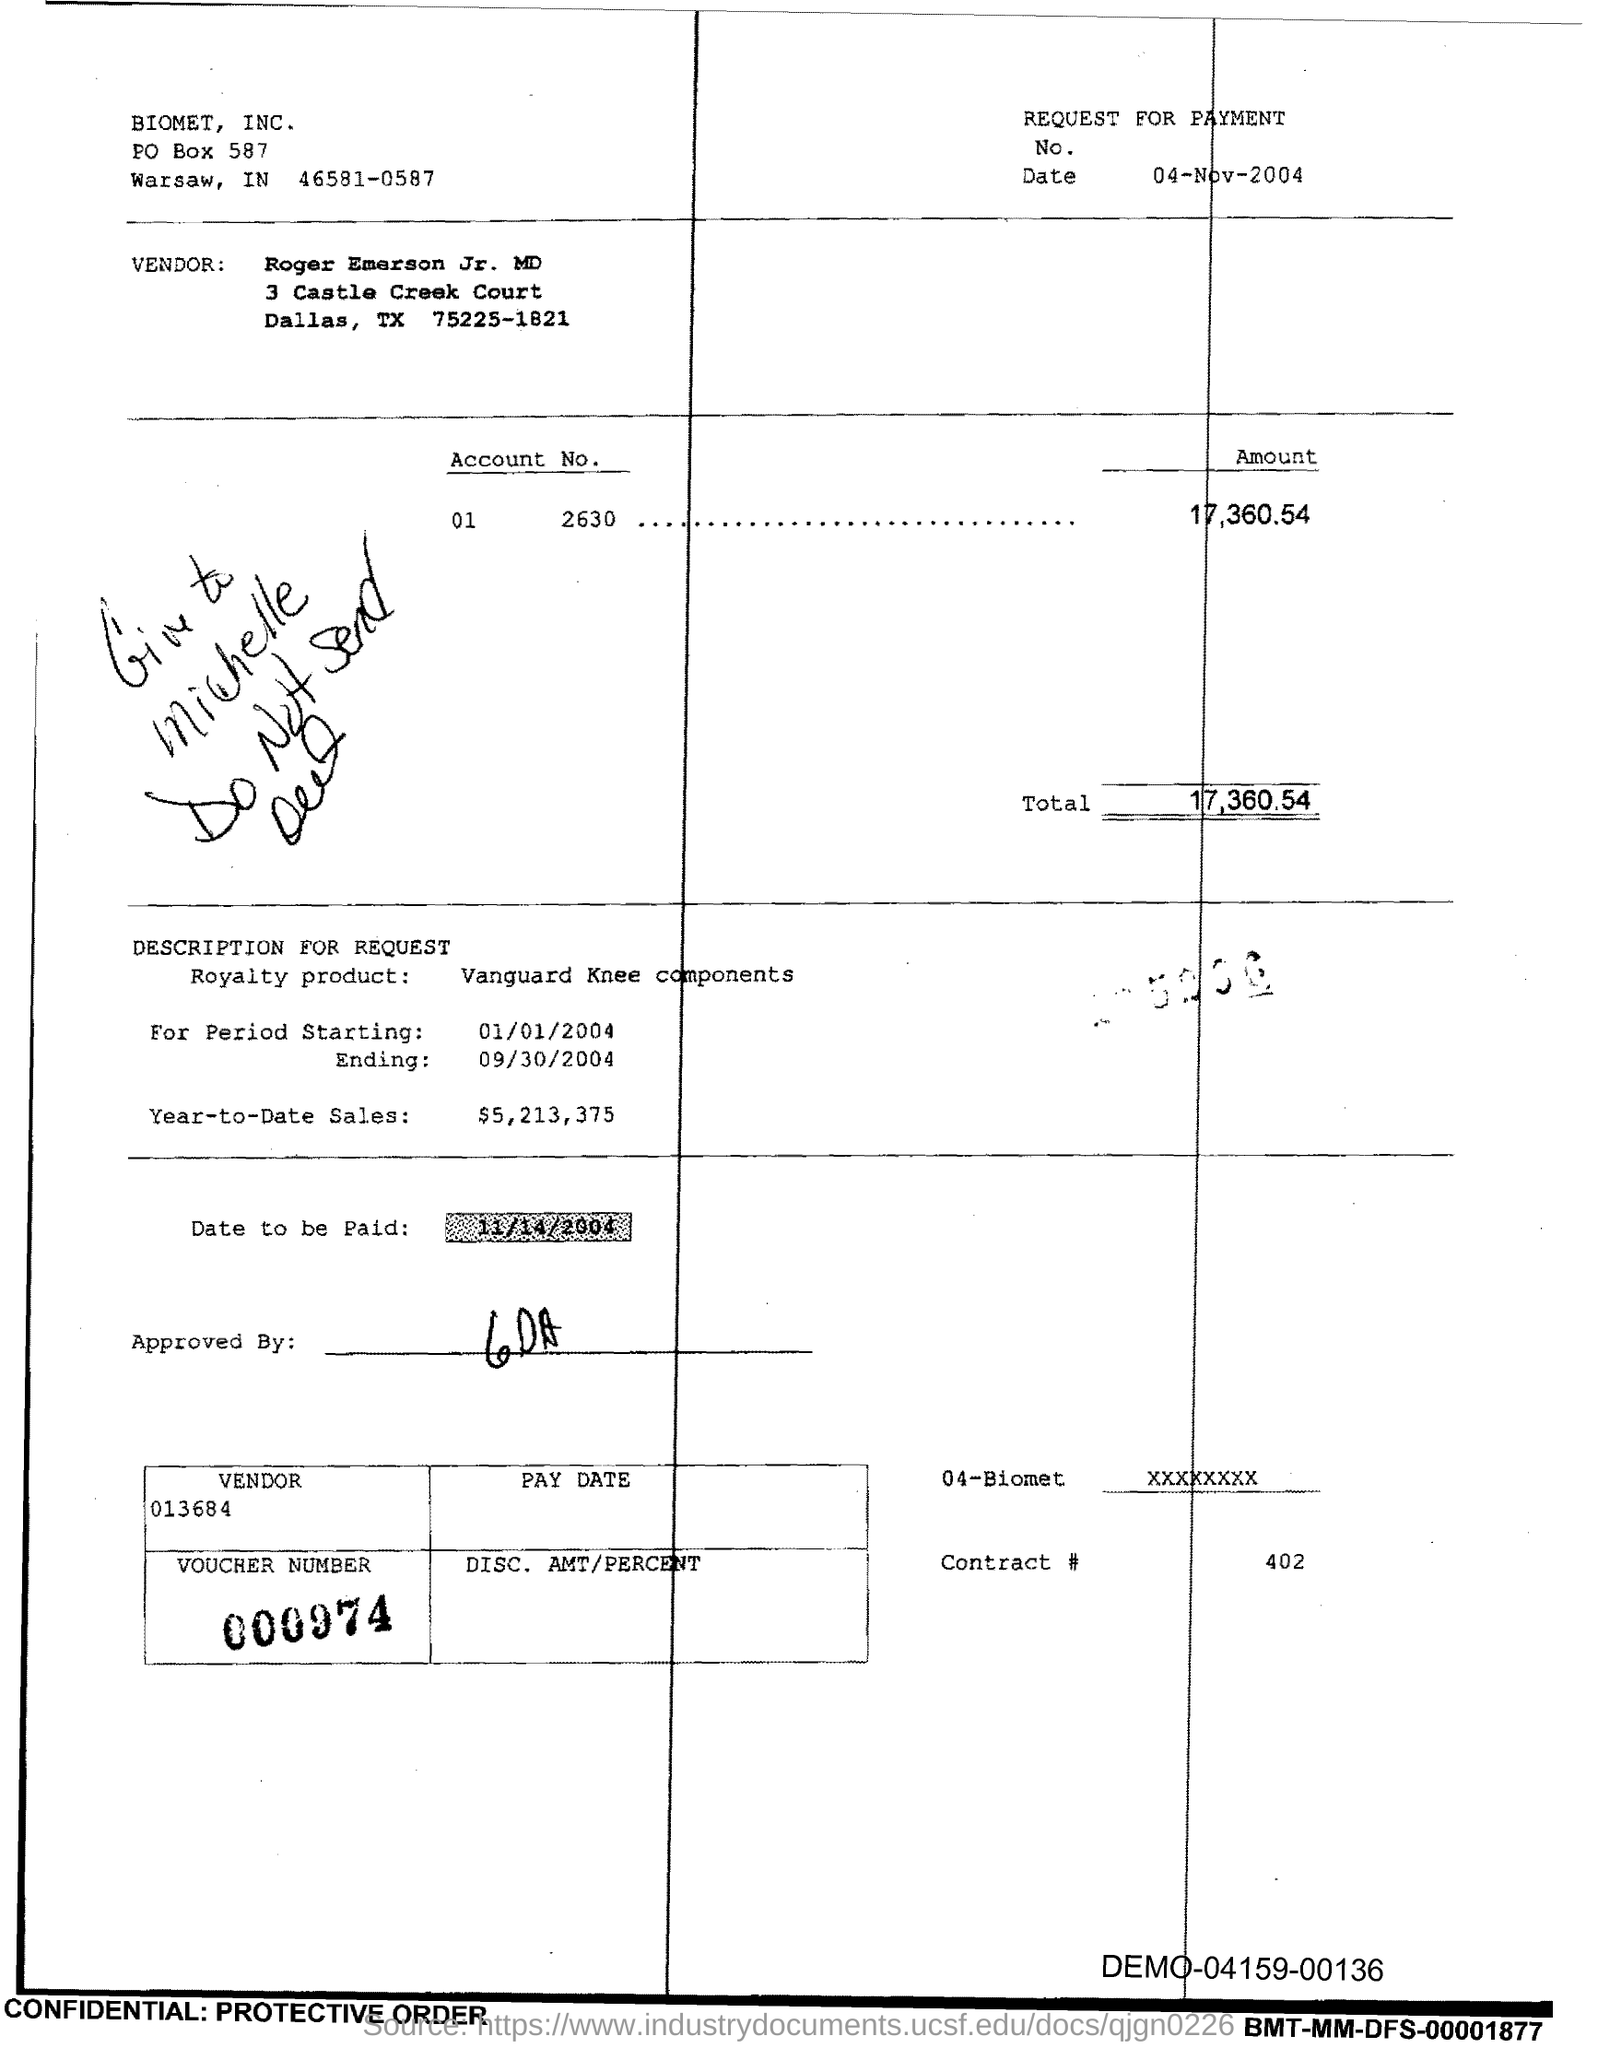Point out several critical features in this image. The contract number is 402, as declared. The total is 17,360.54. The PO Box number mentioned in the document is 587. 